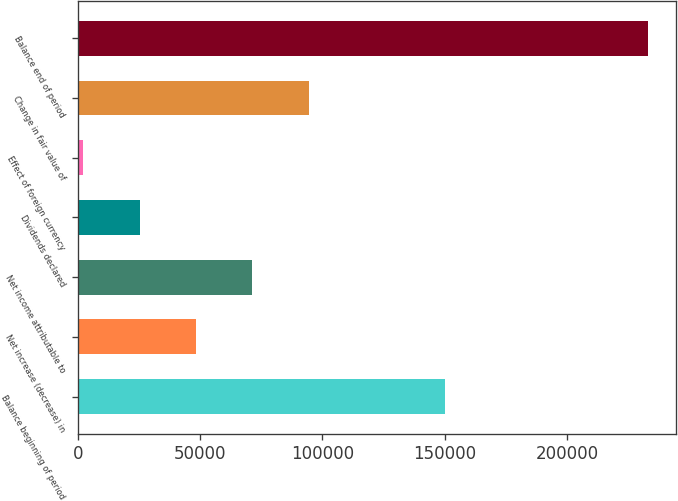Convert chart to OTSL. <chart><loc_0><loc_0><loc_500><loc_500><bar_chart><fcel>Balance beginning of period<fcel>Net increase (decrease) in<fcel>Net income attributable to<fcel>Dividends declared<fcel>Effect of foreign currency<fcel>Change in fair value of<fcel>Balance end of period<nl><fcel>150028<fcel>48255<fcel>71352.5<fcel>25157.5<fcel>2060<fcel>94450<fcel>233035<nl></chart> 